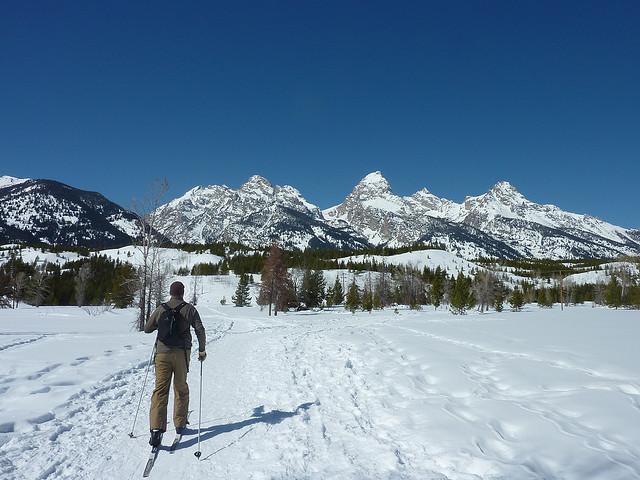How many people are in the picture?
Give a very brief answer. 1. How many people are visible?
Give a very brief answer. 1. 